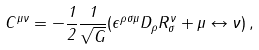<formula> <loc_0><loc_0><loc_500><loc_500>C ^ { \mu \nu } = - \frac { 1 } { 2 } \frac { 1 } { \sqrt { G } } ( \epsilon ^ { \rho \sigma \mu } D _ { \rho } R ^ { \nu } _ { \sigma } + \mu \leftrightarrow \nu ) \, ,</formula> 